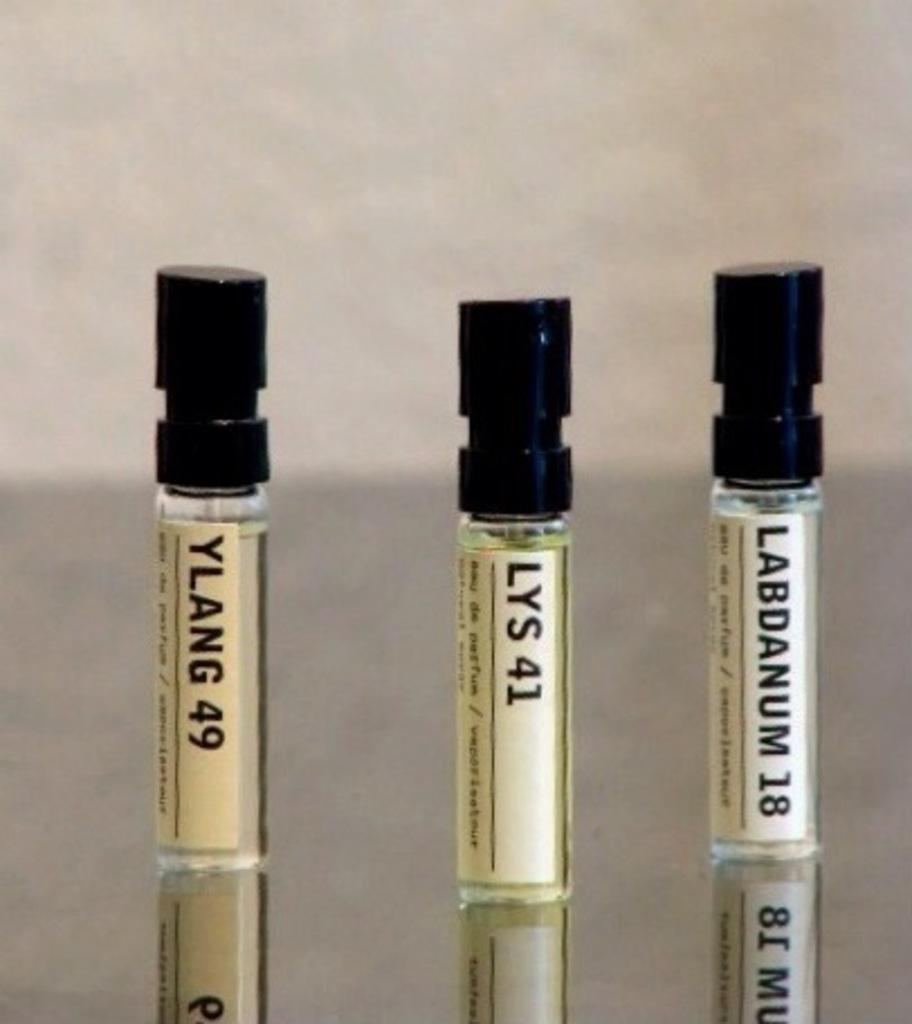Provide a one-sentence caption for the provided image. Three vials with Ylang 49, Lys 41 and Labdanum 18 written on them. 